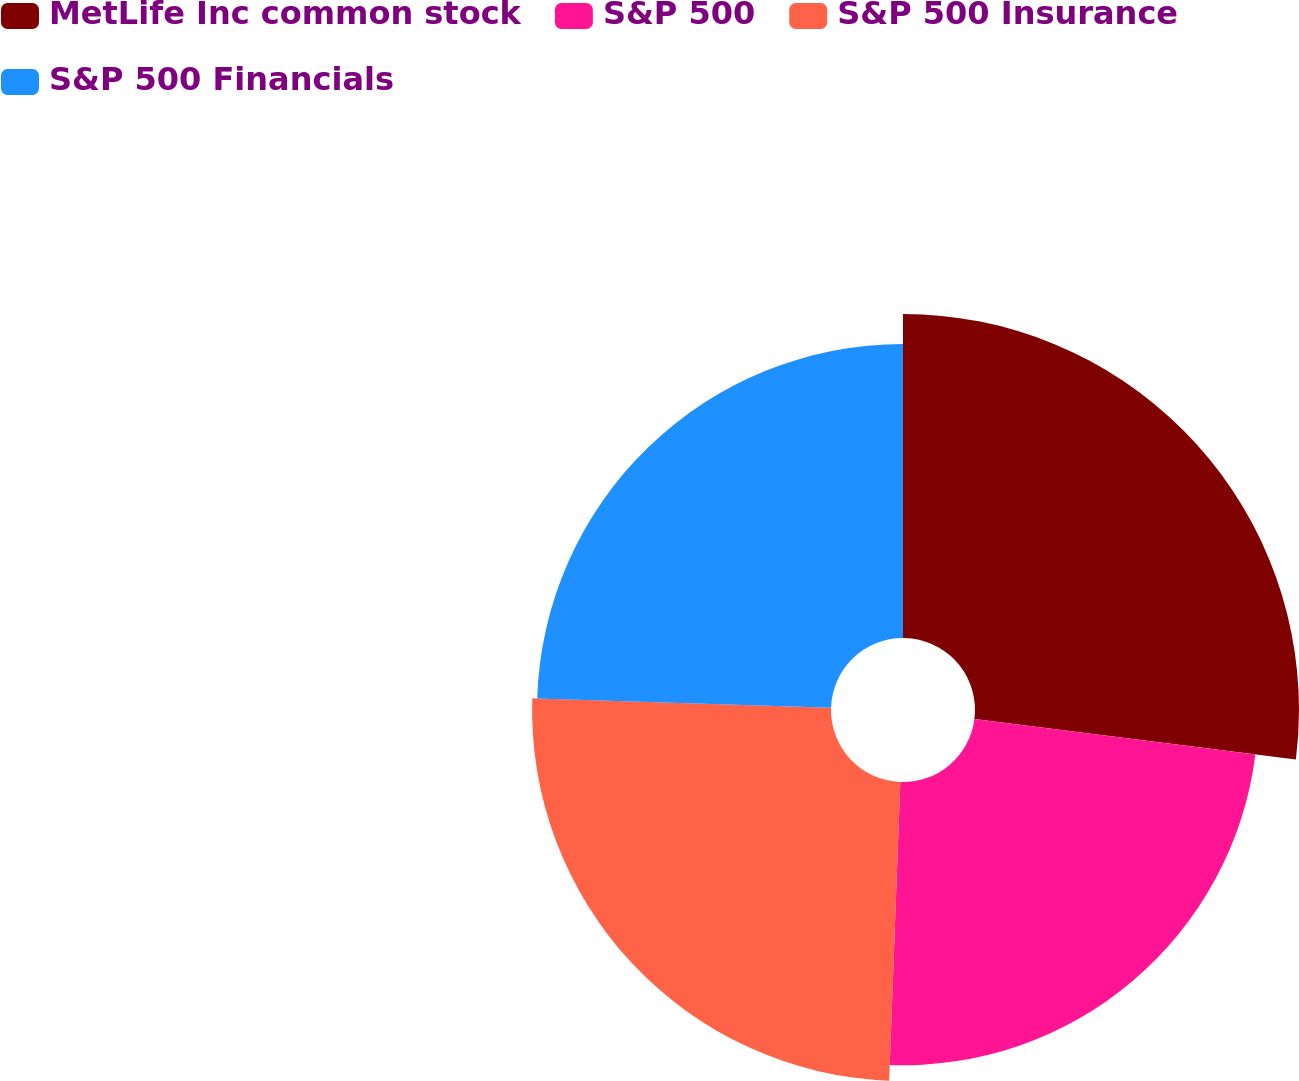<chart> <loc_0><loc_0><loc_500><loc_500><pie_chart><fcel>MetLife Inc common stock<fcel>S&P 500<fcel>S&P 500 Insurance<fcel>S&P 500 Financials<nl><fcel>27.0%<fcel>23.6%<fcel>24.91%<fcel>24.5%<nl></chart> 